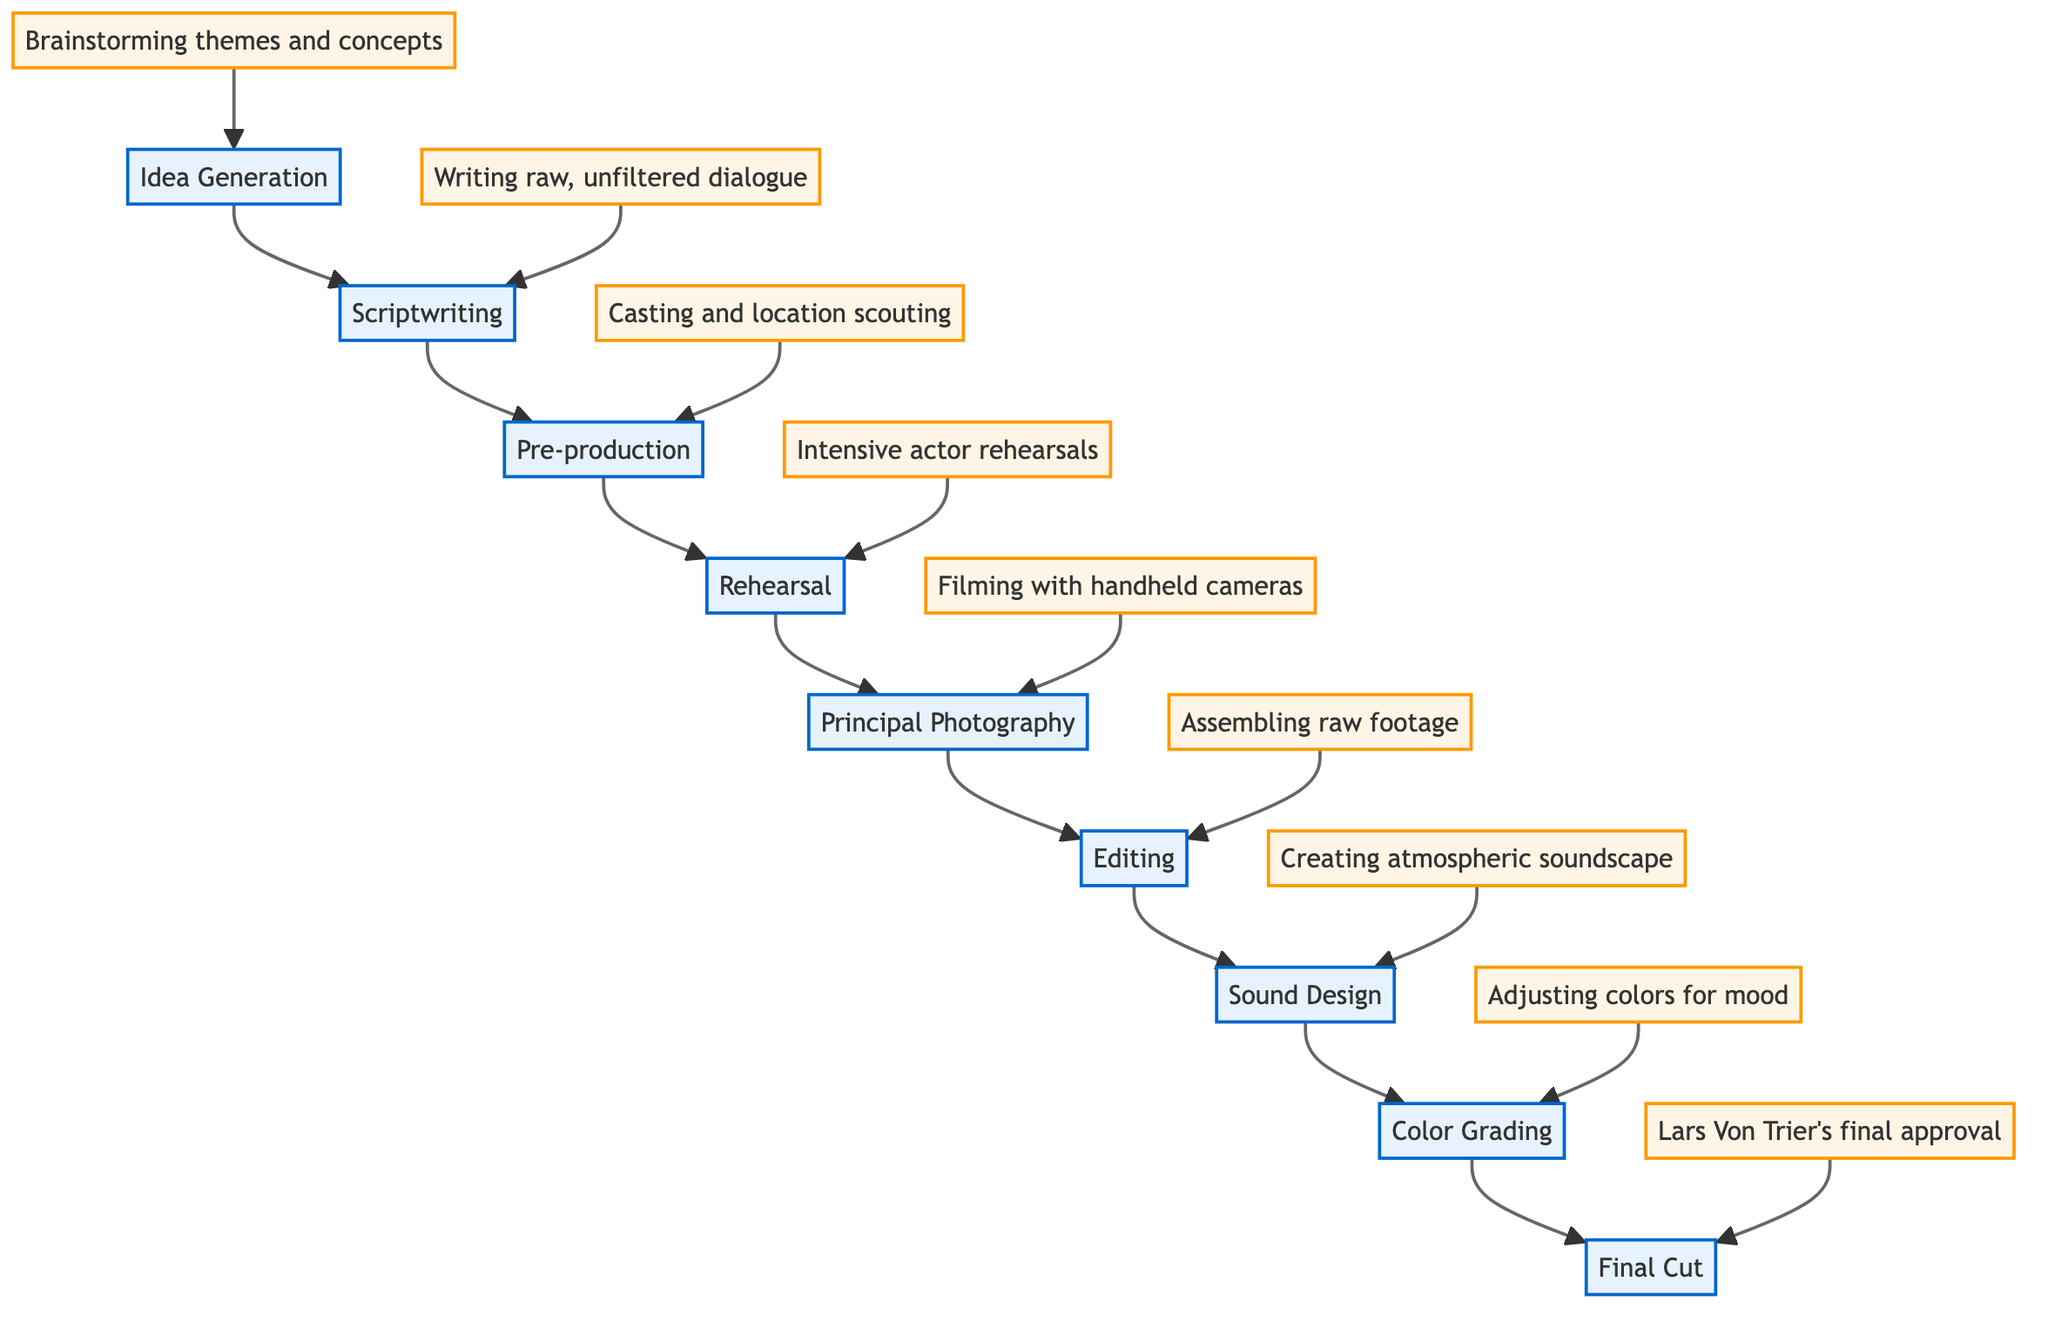What is the first step in the creative process? The flow chart indicates that the first step is "Idea Generation", which is the starting point of the process.
Answer: Idea Generation How many total steps are there in the process? By counting the steps listed in the diagram, from "Idea Generation" to "Final Cut", there are nine distinct steps.
Answer: Nine Which step involves filming scenes? The step referred to for filming scenes is "Principal Photography", as denoted in the flow chart.
Answer: Principal Photography What follows Editing in the creative process? According to the diagram, the step that comes after "Editing" is "Sound Design".
Answer: Sound Design What is emphasized in the rehearsal stage? The diagram notes that "Intensive actor rehearsals" are a key focus during the Rehearsal stage, highlighting the method of preparation for actors.
Answer: Intensive actor rehearsals Which step directly leads to Lars Von Trier's approval? The step preceding "Final Cut" is "Color Grading", meaning that it must be completed before reaching the final approval stage.
Answer: Color Grading What type of camera work is used during Principal Photography? The diagram specifies that "Filming with handheld cameras" is the technique emphasized during this stage, indicating a unique style.
Answer: Filming with handheld cameras How does Sound Design contribute to the overall mood? The flow chart indicates that the "Creating atmospheric soundscape" in Sound Design plays a significant role in enhancing the film's atmosphere.
Answer: Creating atmospheric soundscape What is one characteristic of the scriptwriting process? The description under the "Scriptwriting" step indicates that it focuses on "Writing raw, unfiltered dialogue", which is crucial to this phase.
Answer: Writing raw, unfiltered dialogue 